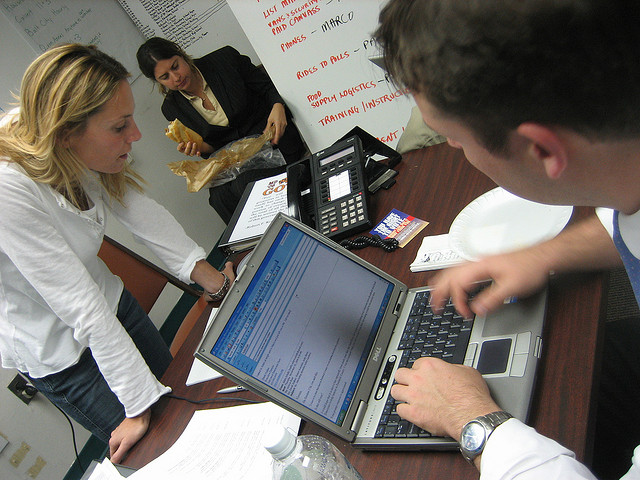Extract all visible text content from this image. LIST PHONES MARCO RIDES TO FOOD POLLS PA CANVASS PAID LOGISTICS SUPPLY NT INSTRU TRAINING GO 